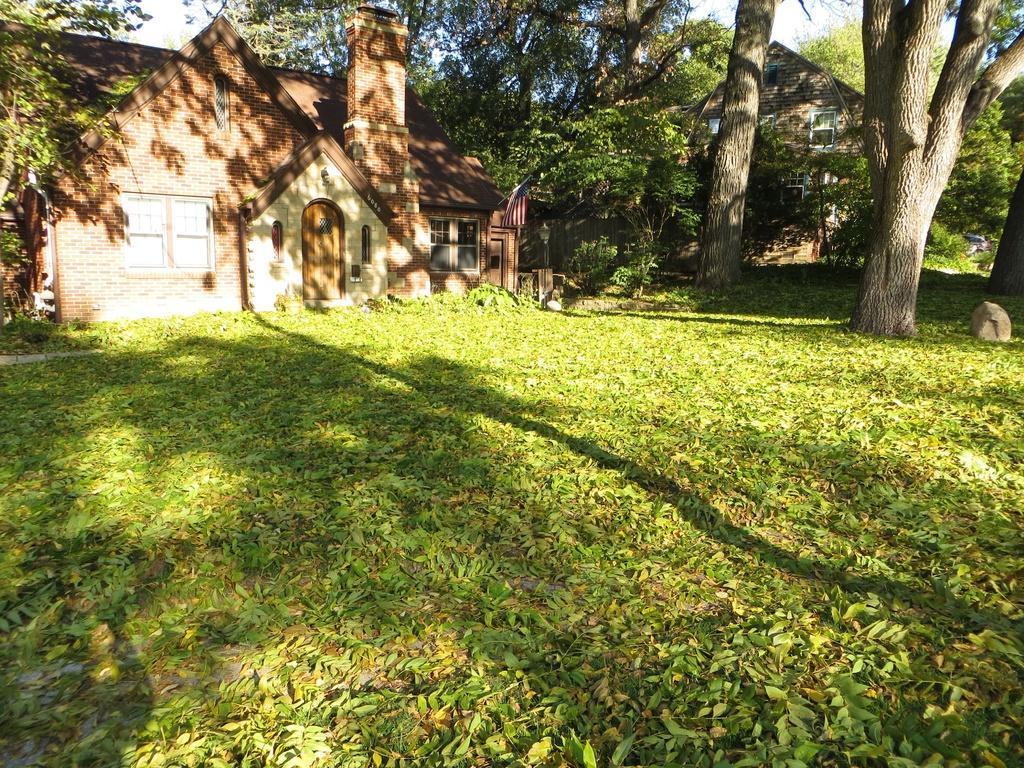How would you summarize this image in a sentence or two? In this image there are plants and grass on the ground. To the left there is a house. On the house there is a flag. In the background there are trees and a house. At the top there is the sky. To the right there is a rock on the ground. 